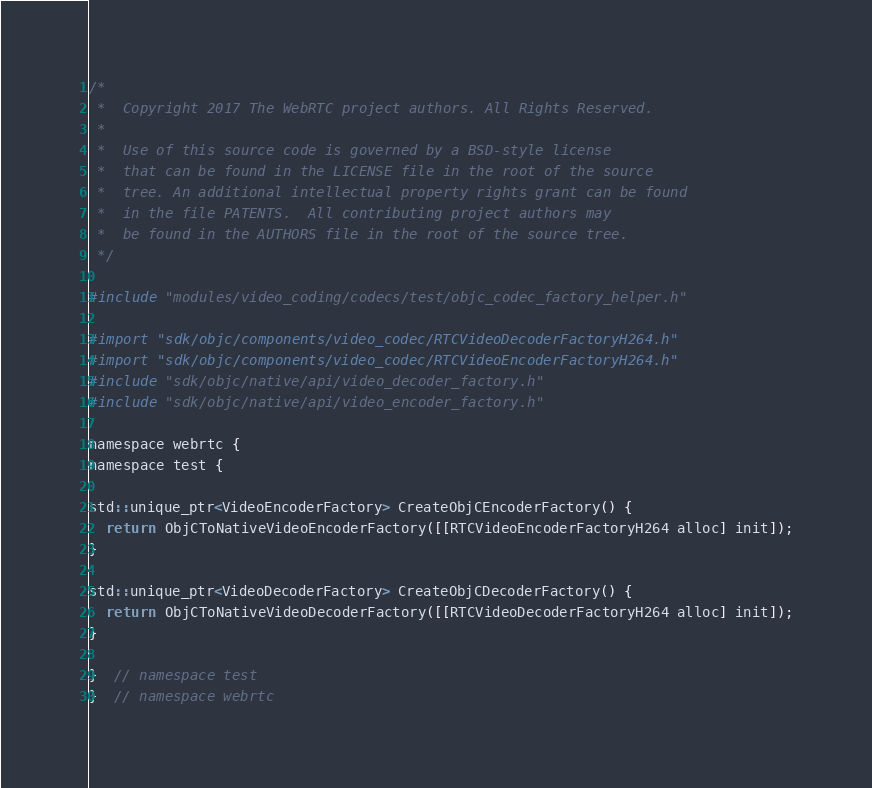<code> <loc_0><loc_0><loc_500><loc_500><_ObjectiveC_>/*
 *  Copyright 2017 The WebRTC project authors. All Rights Reserved.
 *
 *  Use of this source code is governed by a BSD-style license
 *  that can be found in the LICENSE file in the root of the source
 *  tree. An additional intellectual property rights grant can be found
 *  in the file PATENTS.  All contributing project authors may
 *  be found in the AUTHORS file in the root of the source tree.
 */

#include "modules/video_coding/codecs/test/objc_codec_factory_helper.h"

#import "sdk/objc/components/video_codec/RTCVideoDecoderFactoryH264.h"
#import "sdk/objc/components/video_codec/RTCVideoEncoderFactoryH264.h"
#include "sdk/objc/native/api/video_decoder_factory.h"
#include "sdk/objc/native/api/video_encoder_factory.h"

namespace webrtc {
namespace test {

std::unique_ptr<VideoEncoderFactory> CreateObjCEncoderFactory() {
  return ObjCToNativeVideoEncoderFactory([[RTCVideoEncoderFactoryH264 alloc] init]);
}

std::unique_ptr<VideoDecoderFactory> CreateObjCDecoderFactory() {
  return ObjCToNativeVideoDecoderFactory([[RTCVideoDecoderFactoryH264 alloc] init]);
}

}  // namespace test
}  // namespace webrtc
</code> 